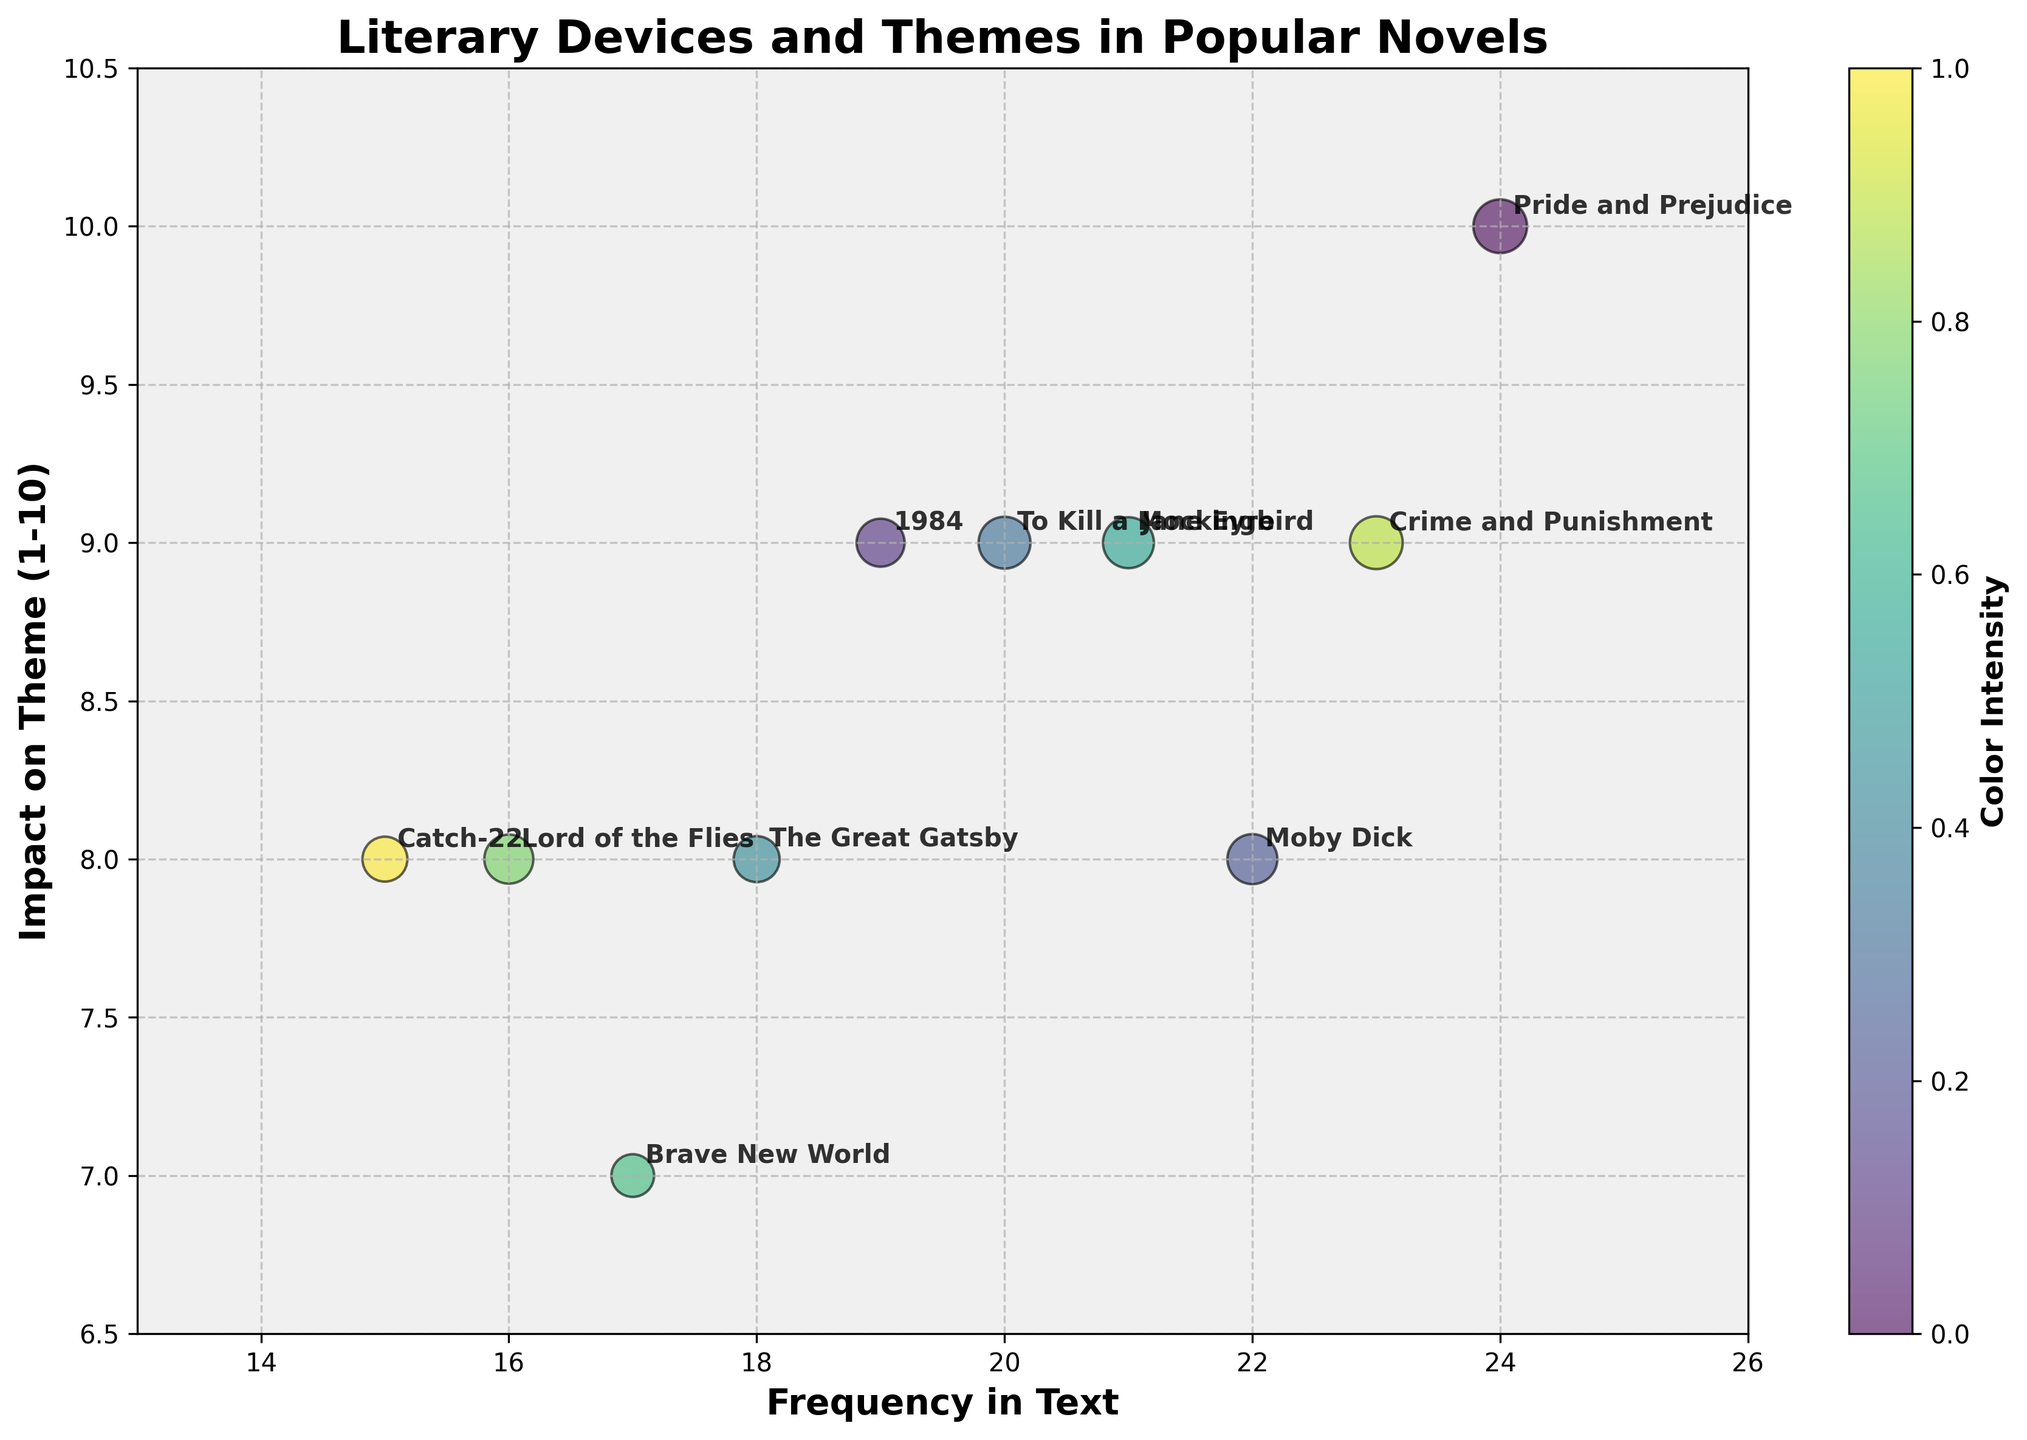What's the title of the chart? The title is prominently displayed at the top of the chart. It reads 'Literary Devices and Themes in Popular Novels'.
Answer: 'Literary Devices and Themes in Popular Novels' Which book is associated with the highest impact on theme? By looking at the y-axis, the highest impact on theme is at a value of 10, and only one bubble corresponds to this value. The label next to this bubble is 'Pride and Prejudice'.
Answer: 'Pride and Prejudice' How many books have an impact on theme rating of 9? From the y-axis and the corresponding bubbles, there are four bubbles with an impact rating of 9: '1984', 'To Kill a Mockingbird', 'Jane Eyre', and 'Crime and Punishment'.
Answer: Four Which literary device has the largest bubble size? The largest bubble, as noted in the legend and chart, corresponds to 'Pride and Prejudice', which uses Irony as its literary device.
Answer: Irony What is the frequency in text for 'The Great Gatsby'? 'The Great Gatsby' bubble can be identified and is positioned at a frequency value on the x-axis of 18.
Answer: 18 What are the themes of novels with an impact on theme rating of 8? There are four bubbles with an impact rating of 8: 'Moby Dick' (Nature of Good and Evil), 'The Great Gatsby' (American Dream), 'Lord of the Flies' (Civilization vs. Savagery), 'Catch-22' (Absurdity of War).
Answer: Nature of Good and Evil, American Dream, Civilization vs. Savagery, Absurdity of War Which novel has the smallest bubble size, and what is its frequency in text and impact on theme? The smallest bubble, as seen in relative bubble sizes, belongs to 'Brave New World'. It has a frequency in text of 17 and an impact on theme rating of 7.
Answer: 'Brave New World', Frequency: 17, Impact: 7 Is there a correlation between frequency in text and impact on theme? By observing the chart and the placement of the bubbles, there does not appear to be a clear linear correlation between the frequency in text (x-axis) and the impact on theme (y-axis). The bubbles are rather scattered.
Answer: No clear correlation What is the average impact on theme for the novels by female authors? Female authors listed: 'Pride and Prejudice' (10), 'To Kill a Mockingbird' (9), 'Jane Eyre' (9). The average impact is calculated as (10 + 9 + 9)/3.
Answer: 9.33 Which two novels have the closest frequency in text values, and what are their frequencies? 'Catch-22' and 'Lord of the Flies' are close in frequency with values of 15 and 16, respectively.
Answer: 'Catch-22': 15, 'Lord of the Flies': 16 